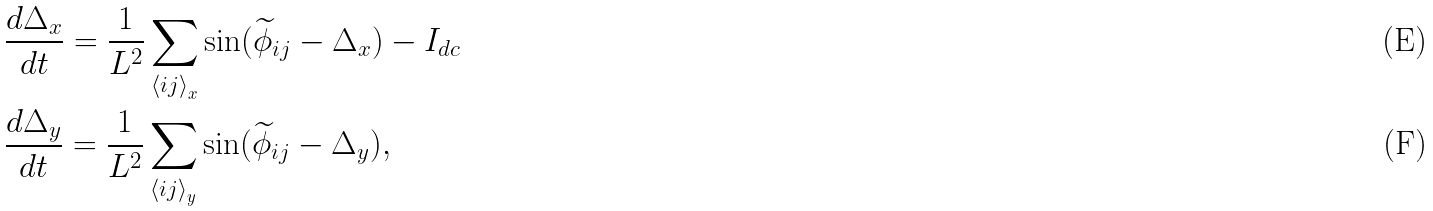Convert formula to latex. <formula><loc_0><loc_0><loc_500><loc_500>& \frac { d \Delta _ { x } } { d t } = \frac { 1 } { L ^ { 2 } } \sum _ { { \langle i j \rangle } _ { x } } \sin ( { \widetilde { \phi } } _ { i j } - \Delta _ { x } ) - I _ { d c } \\ & \frac { d \Delta _ { y } } { d t } = \frac { 1 } { L ^ { 2 } } \sum _ { { \langle i j \rangle } _ { y } } \sin ( { \widetilde { \phi } } _ { i j } - \Delta _ { y } ) ,</formula> 